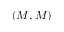<formula> <loc_0><loc_0><loc_500><loc_500>( M , M )</formula> 